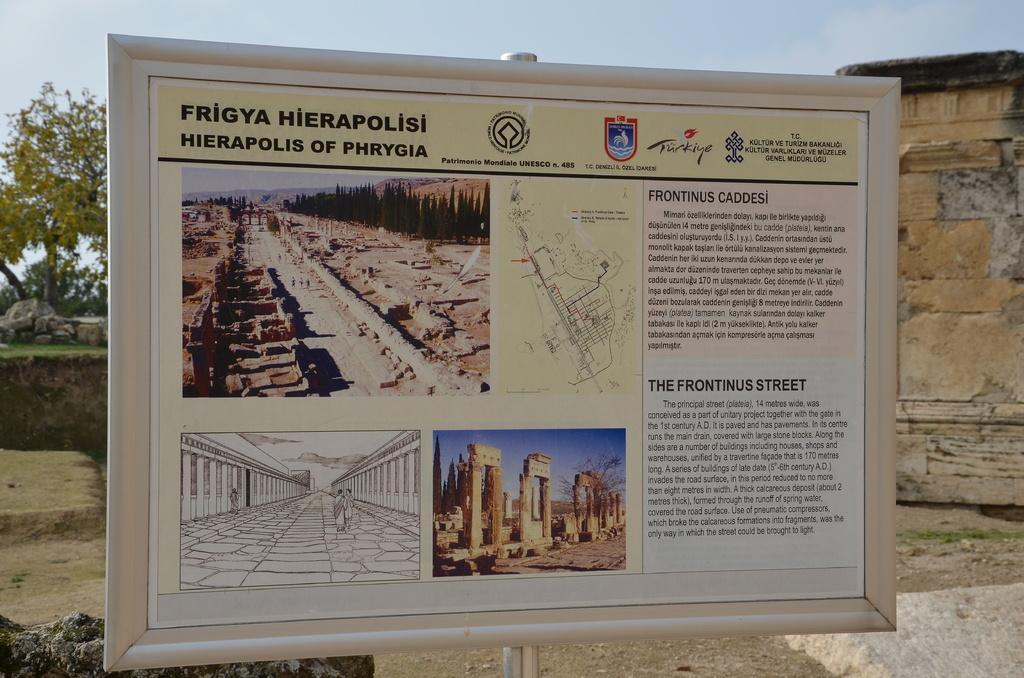How would you summarize this image in a sentence or two? In this image, we can see a board with some images and text. We can see the wall and the ground. We can also see some grass, rocks and trees. We can also see the sky. 